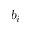<formula> <loc_0><loc_0><loc_500><loc_500>b _ { i }</formula> 